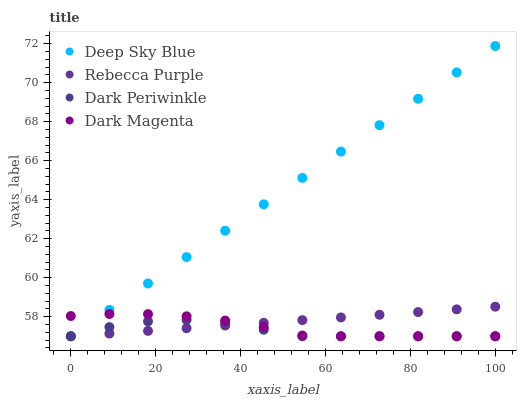Does Dark Periwinkle have the minimum area under the curve?
Answer yes or no. Yes. Does Deep Sky Blue have the maximum area under the curve?
Answer yes or no. Yes. Does Rebecca Purple have the minimum area under the curve?
Answer yes or no. No. Does Rebecca Purple have the maximum area under the curve?
Answer yes or no. No. Is Rebecca Purple the smoothest?
Answer yes or no. Yes. Is Dark Periwinkle the roughest?
Answer yes or no. Yes. Is Deep Sky Blue the smoothest?
Answer yes or no. No. Is Deep Sky Blue the roughest?
Answer yes or no. No. Does Dark Magenta have the lowest value?
Answer yes or no. Yes. Does Deep Sky Blue have the highest value?
Answer yes or no. Yes. Does Rebecca Purple have the highest value?
Answer yes or no. No. Does Dark Magenta intersect Deep Sky Blue?
Answer yes or no. Yes. Is Dark Magenta less than Deep Sky Blue?
Answer yes or no. No. Is Dark Magenta greater than Deep Sky Blue?
Answer yes or no. No. 